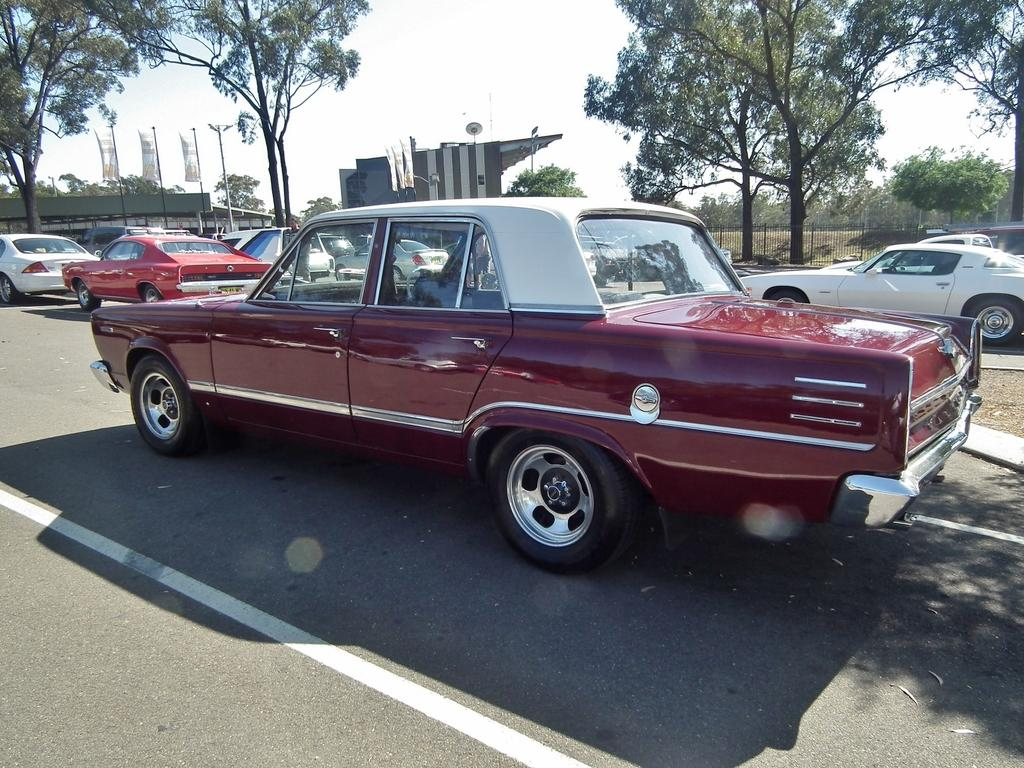What types of vehicles can be seen on the road in the image? There are vehicles on the road in the image. What natural elements are present in the image? There are trees in the image. What man-made structures are visible in the image? There are buildings in the image. What safety feature is present in the image? There is railing in the image. What part of the natural environment is visible in the image? The sky is visible in the image. Where can the honey be found in the image? There is no honey present in the image. How many babies are visible in the image? There are no babies present in the image. What type of notebook is being used by the people in the image? There are no people or notebooks present in the image. 